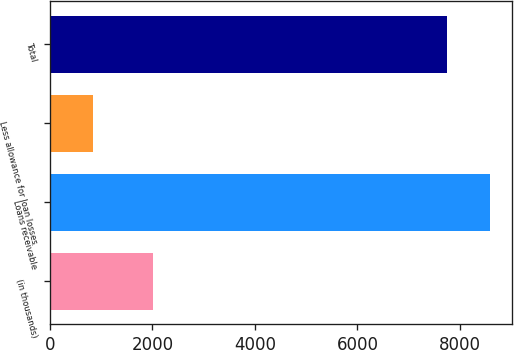Convert chart. <chart><loc_0><loc_0><loc_500><loc_500><bar_chart><fcel>(in thousands)<fcel>Loans receivable<fcel>Less allowance for loan losses<fcel>Total<nl><fcel>2009<fcel>8593<fcel>838<fcel>7755<nl></chart> 